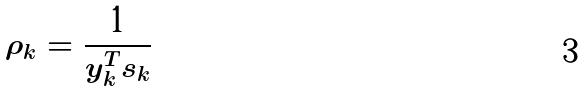<formula> <loc_0><loc_0><loc_500><loc_500>\rho _ { k } = \frac { 1 } { y _ { k } ^ { T } s _ { k } }</formula> 